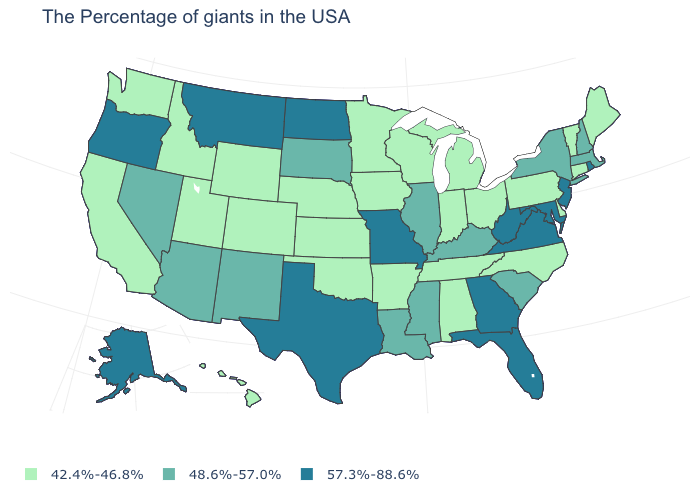Does the map have missing data?
Be succinct. No. Which states have the highest value in the USA?
Give a very brief answer. Rhode Island, New Jersey, Maryland, Virginia, West Virginia, Florida, Georgia, Missouri, Texas, North Dakota, Montana, Oregon, Alaska. What is the value of Washington?
Answer briefly. 42.4%-46.8%. What is the highest value in states that border Louisiana?
Concise answer only. 57.3%-88.6%. What is the value of Delaware?
Quick response, please. 42.4%-46.8%. What is the highest value in the USA?
Short answer required. 57.3%-88.6%. Name the states that have a value in the range 57.3%-88.6%?
Keep it brief. Rhode Island, New Jersey, Maryland, Virginia, West Virginia, Florida, Georgia, Missouri, Texas, North Dakota, Montana, Oregon, Alaska. Name the states that have a value in the range 57.3%-88.6%?
Write a very short answer. Rhode Island, New Jersey, Maryland, Virginia, West Virginia, Florida, Georgia, Missouri, Texas, North Dakota, Montana, Oregon, Alaska. Which states have the lowest value in the South?
Short answer required. Delaware, North Carolina, Alabama, Tennessee, Arkansas, Oklahoma. Does Maine have a higher value than Vermont?
Concise answer only. No. Does New Hampshire have the same value as North Dakota?
Give a very brief answer. No. Does Alaska have a higher value than North Dakota?
Quick response, please. No. Among the states that border Pennsylvania , which have the highest value?
Quick response, please. New Jersey, Maryland, West Virginia. What is the value of Nebraska?
Keep it brief. 42.4%-46.8%. 